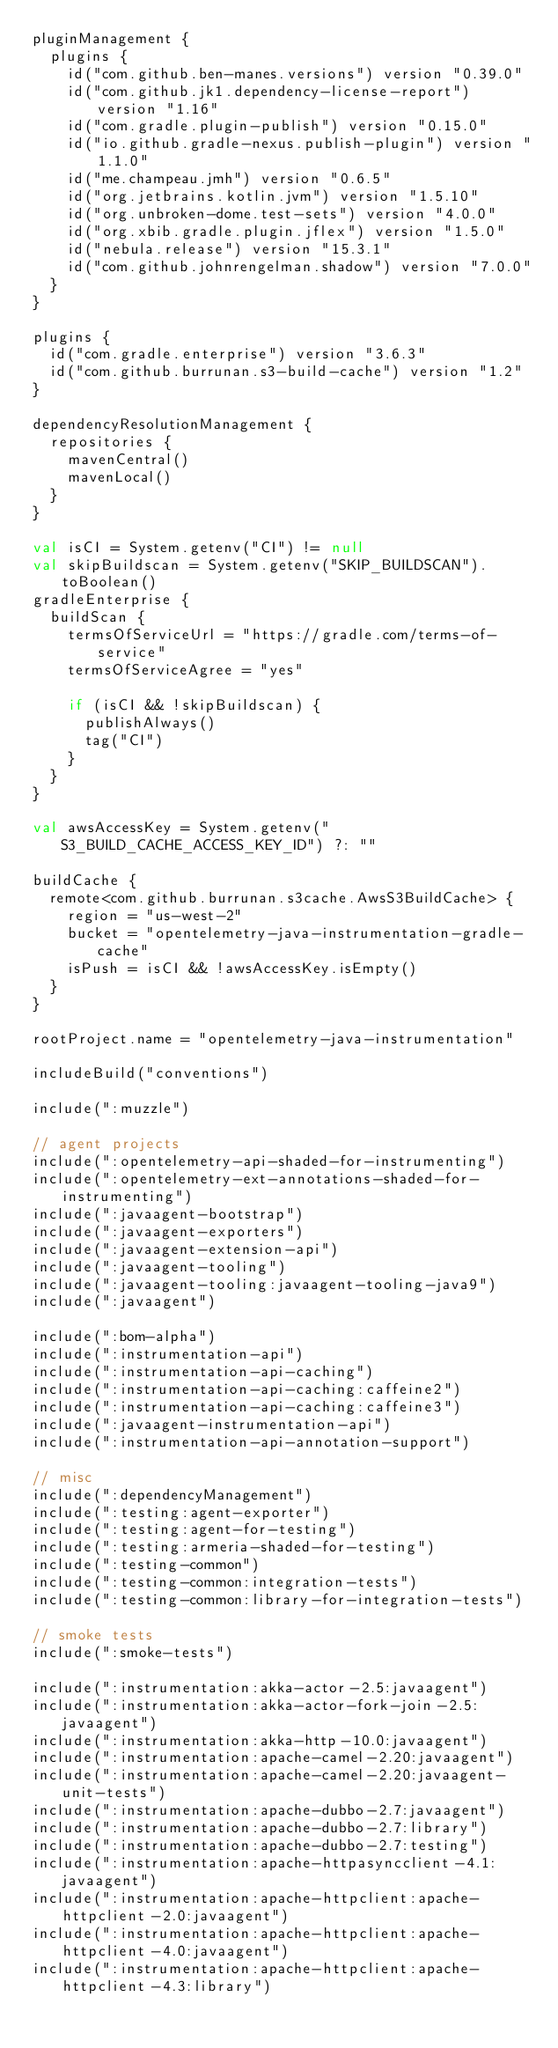Convert code to text. <code><loc_0><loc_0><loc_500><loc_500><_Kotlin_>pluginManagement {
  plugins {
    id("com.github.ben-manes.versions") version "0.39.0"
    id("com.github.jk1.dependency-license-report") version "1.16"
    id("com.gradle.plugin-publish") version "0.15.0"
    id("io.github.gradle-nexus.publish-plugin") version "1.1.0"
    id("me.champeau.jmh") version "0.6.5"
    id("org.jetbrains.kotlin.jvm") version "1.5.10"
    id("org.unbroken-dome.test-sets") version "4.0.0"
    id("org.xbib.gradle.plugin.jflex") version "1.5.0"
    id("nebula.release") version "15.3.1"
    id("com.github.johnrengelman.shadow") version "7.0.0"
  }
}

plugins {
  id("com.gradle.enterprise") version "3.6.3"
  id("com.github.burrunan.s3-build-cache") version "1.2"
}

dependencyResolutionManagement {
  repositories {
    mavenCentral()
    mavenLocal()
  }
}

val isCI = System.getenv("CI") != null
val skipBuildscan = System.getenv("SKIP_BUILDSCAN").toBoolean()
gradleEnterprise {
  buildScan {
    termsOfServiceUrl = "https://gradle.com/terms-of-service"
    termsOfServiceAgree = "yes"

    if (isCI && !skipBuildscan) {
      publishAlways()
      tag("CI")
    }
  }
}

val awsAccessKey = System.getenv("S3_BUILD_CACHE_ACCESS_KEY_ID") ?: ""

buildCache {
  remote<com.github.burrunan.s3cache.AwsS3BuildCache> {
    region = "us-west-2"
    bucket = "opentelemetry-java-instrumentation-gradle-cache"
    isPush = isCI && !awsAccessKey.isEmpty()
  }
}

rootProject.name = "opentelemetry-java-instrumentation"

includeBuild("conventions")

include(":muzzle")

// agent projects
include(":opentelemetry-api-shaded-for-instrumenting")
include(":opentelemetry-ext-annotations-shaded-for-instrumenting")
include(":javaagent-bootstrap")
include(":javaagent-exporters")
include(":javaagent-extension-api")
include(":javaagent-tooling")
include(":javaagent-tooling:javaagent-tooling-java9")
include(":javaagent")

include(":bom-alpha")
include(":instrumentation-api")
include(":instrumentation-api-caching")
include(":instrumentation-api-caching:caffeine2")
include(":instrumentation-api-caching:caffeine3")
include(":javaagent-instrumentation-api")
include(":instrumentation-api-annotation-support")

// misc
include(":dependencyManagement")
include(":testing:agent-exporter")
include(":testing:agent-for-testing")
include(":testing:armeria-shaded-for-testing")
include(":testing-common")
include(":testing-common:integration-tests")
include(":testing-common:library-for-integration-tests")

// smoke tests
include(":smoke-tests")

include(":instrumentation:akka-actor-2.5:javaagent")
include(":instrumentation:akka-actor-fork-join-2.5:javaagent")
include(":instrumentation:akka-http-10.0:javaagent")
include(":instrumentation:apache-camel-2.20:javaagent")
include(":instrumentation:apache-camel-2.20:javaagent-unit-tests")
include(":instrumentation:apache-dubbo-2.7:javaagent")
include(":instrumentation:apache-dubbo-2.7:library")
include(":instrumentation:apache-dubbo-2.7:testing")
include(":instrumentation:apache-httpasyncclient-4.1:javaagent")
include(":instrumentation:apache-httpclient:apache-httpclient-2.0:javaagent")
include(":instrumentation:apache-httpclient:apache-httpclient-4.0:javaagent")
include(":instrumentation:apache-httpclient:apache-httpclient-4.3:library")</code> 